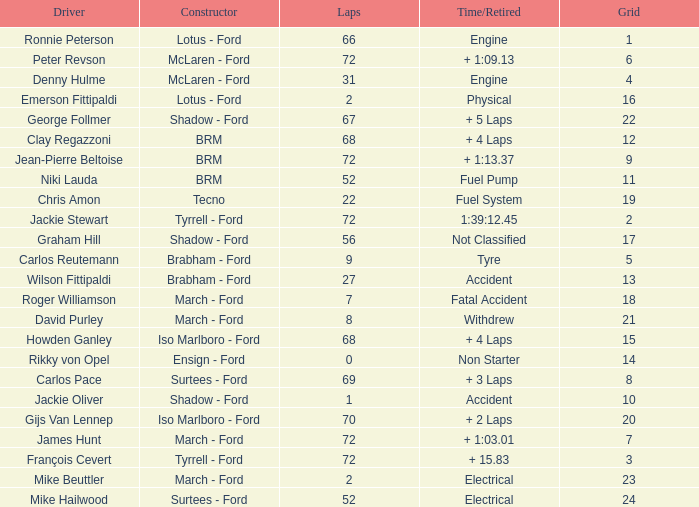What is the top grid that laps less than 66 and a retried engine? 4.0. 